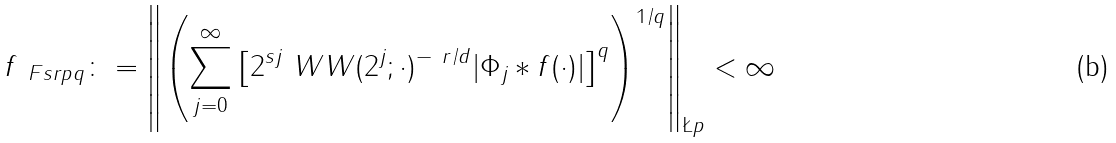Convert formula to latex. <formula><loc_0><loc_0><loc_500><loc_500>\| f \| _ { \ F s r p q } \colon = \left \| \left ( \sum _ { j = 0 } ^ { \infty } \left [ 2 ^ { s j } \ W W ( 2 ^ { j } ; \cdot ) ^ { - \ r / d } | \Phi _ { j } * f ( \cdot ) | \right ] ^ { q } \right ) ^ { 1 / q } \right \| _ { \L p } < \infty</formula> 